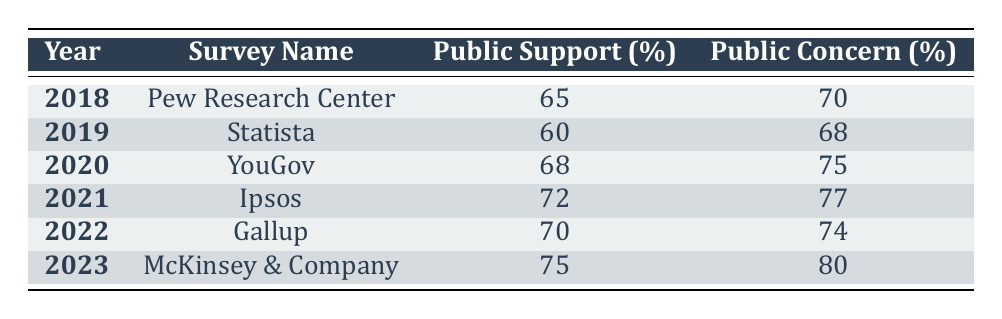What was the public support percentage for the survey conducted in 2021? According to the table, the public support percentage for the Ipsos survey conducted in 2021 is explicitly listed as 72.
Answer: 72 Which year showed the highest public concern percentage? By examining the public concern percentages in the table, 80 in 2023 is the highest value compared to the other years.
Answer: 2023 What is the difference between public support in 2022 and 2019? The public support percentage for Gallup in 2022 is 70, while for Statista in 2019 it is 60. The difference is calculated as 70 - 60 = 10.
Answer: 10 Is the public concern percentage for 2020 greater than that for 2018? Looking at the table, the public concern percentage for 2020 is 75, which is greater than 70 for 2018. Therefore, the answer is yes.
Answer: Yes What is the average public support percentage across all years? To compute the average, we sum up all the public support percentages (65 + 60 + 68 + 72 + 70 + 75 = 410) and divide by the number of years (6). So, 410 / 6 = 68.33, rounded to two decimal places.
Answer: 68.33 Which survey in 2022 showed a public concern percentage lower than 75? In the table, 2022 has a public concern percentage of 74, which is lower than 75, during a comparison with the subsequent year of 2023, which shows 80.
Answer: Gallup What is the public concern percentage trend from 2018 to 2023? By examining the public concern percentages, we see values increase from 70 in 2018 to 80 in 2023, thus indicating a rising trend.
Answer: Rising trend Was the public support percentage consistently above 60 from 2018 to 2023? A review of the public support percentages reveals that all years from 2018 (65) to 2023 (75) are above 60, confirming the statement as true.
Answer: Yes 